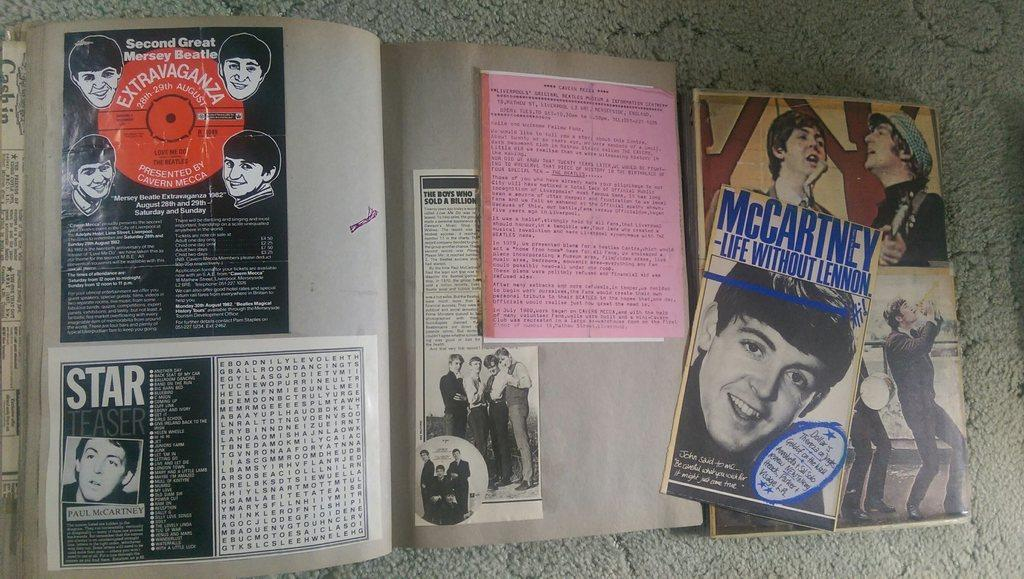<image>
Describe the image concisely. A billboard displays photos and written descriptions of Paul McCartney. 